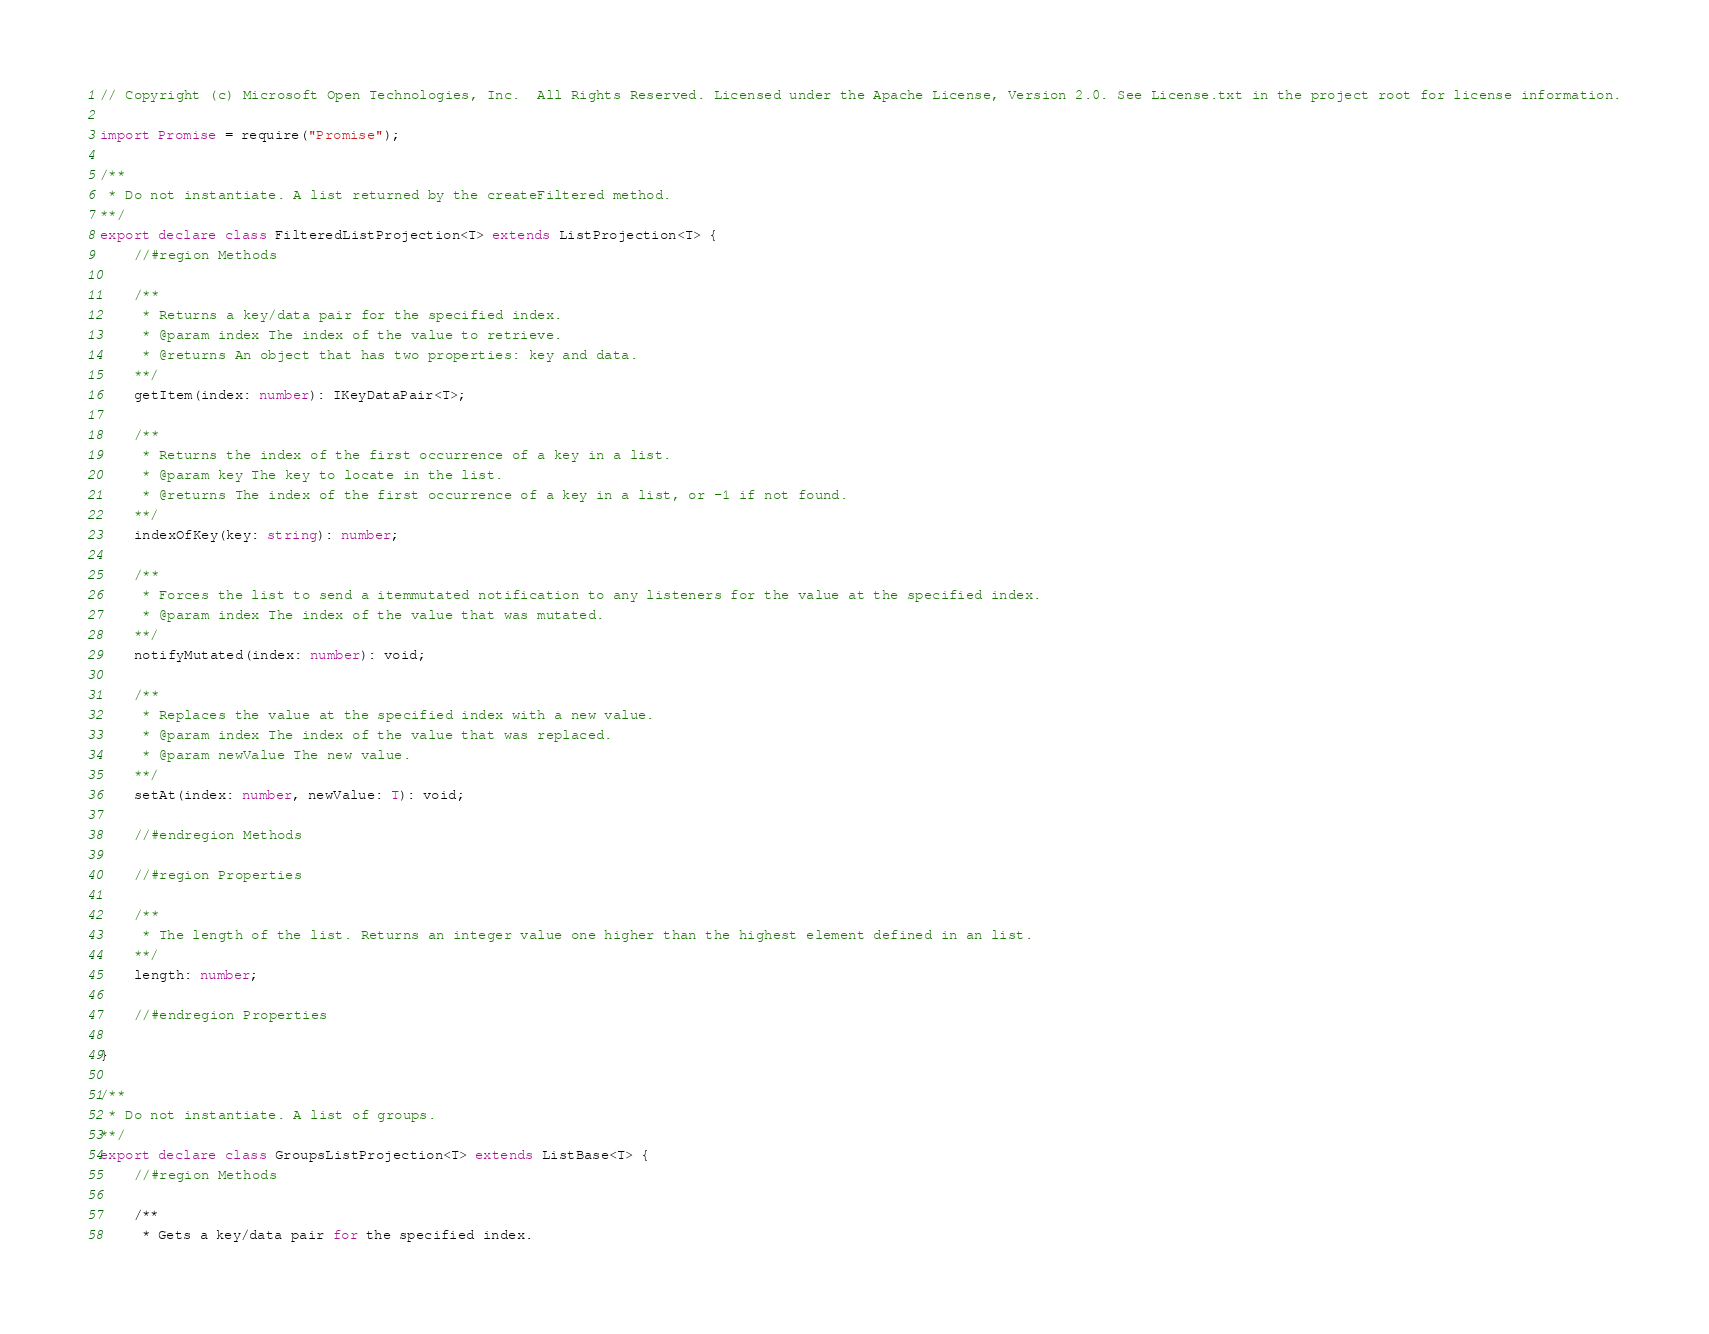Convert code to text. <code><loc_0><loc_0><loc_500><loc_500><_TypeScript_>// Copyright (c) Microsoft Open Technologies, Inc.  All Rights Reserved. Licensed under the Apache License, Version 2.0. See License.txt in the project root for license information.

import Promise = require("Promise");

/**
 * Do not instantiate. A list returned by the createFiltered method.
**/
export declare class FilteredListProjection<T> extends ListProjection<T> {
    //#region Methods

    /**
     * Returns a key/data pair for the specified index.
     * @param index The index of the value to retrieve.
     * @returns An object that has two properties: key and data.
    **/
    getItem(index: number): IKeyDataPair<T>;

    /**
     * Returns the index of the first occurrence of a key in a list.
     * @param key The key to locate in the list.
     * @returns The index of the first occurrence of a key in a list, or -1 if not found.
    **/
    indexOfKey(key: string): number;

    /**
     * Forces the list to send a itemmutated notification to any listeners for the value at the specified index.
     * @param index The index of the value that was mutated.
    **/
    notifyMutated(index: number): void;

    /**
     * Replaces the value at the specified index with a new value.
     * @param index The index of the value that was replaced.
     * @param newValue The new value.
    **/
    setAt(index: number, newValue: T): void;

    //#endregion Methods

    //#region Properties

    /**
     * The length of the list. Returns an integer value one higher than the highest element defined in an list.
    **/
    length: number;

    //#endregion Properties

}

/**
 * Do not instantiate. A list of groups.
**/
export declare class GroupsListProjection<T> extends ListBase<T> {
    //#region Methods

    /**
     * Gets a key/data pair for the specified index.</code> 